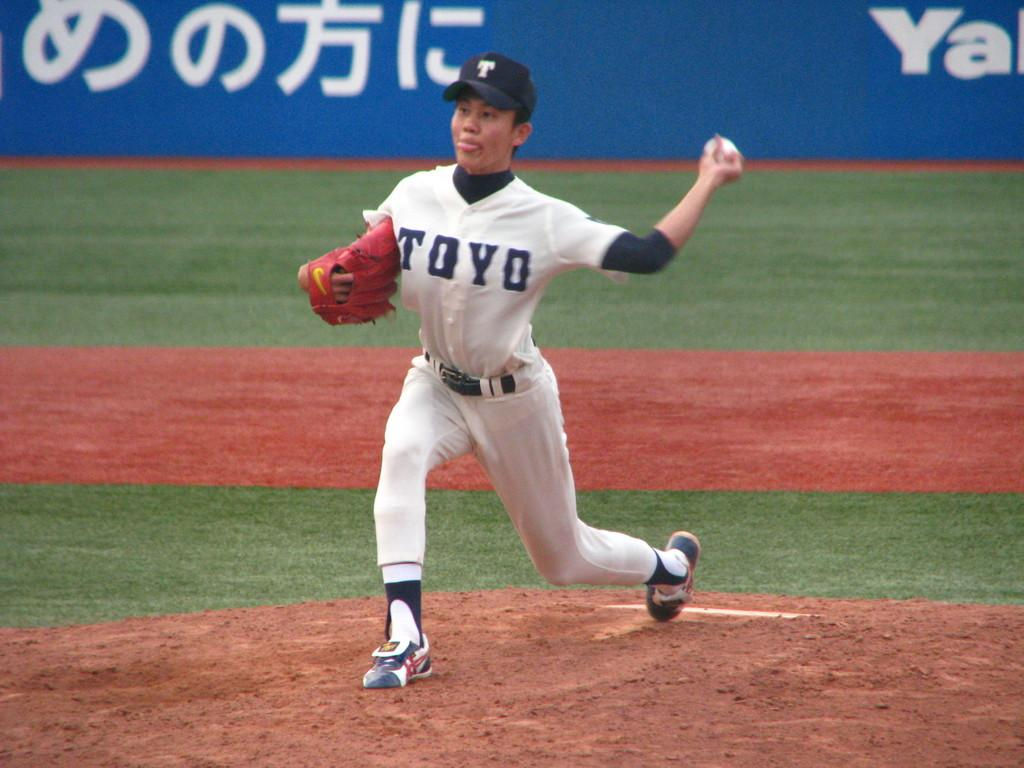<image>
Describe the image concisely. A person in a white top reading TOYO throwing a baseball. 